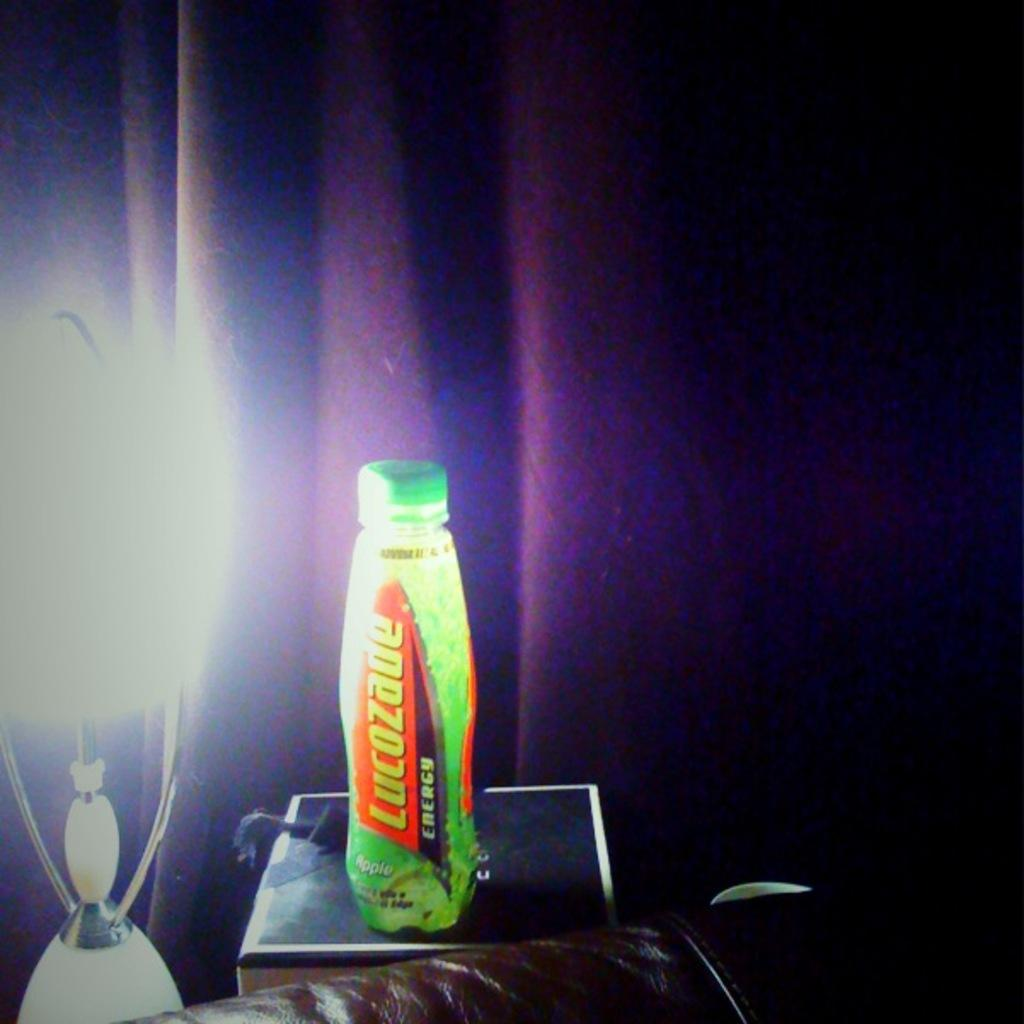<image>
Provide a brief description of the given image. A bottle of Lucozade sits next to a lamp in front of a purple curtain. 